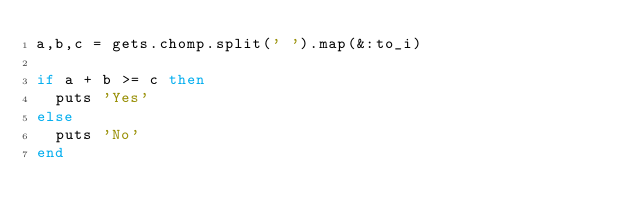<code> <loc_0><loc_0><loc_500><loc_500><_Ruby_>a,b,c = gets.chomp.split(' ').map(&:to_i)
 
if a + b >= c then
  puts 'Yes'
else
  puts 'No'
end</code> 